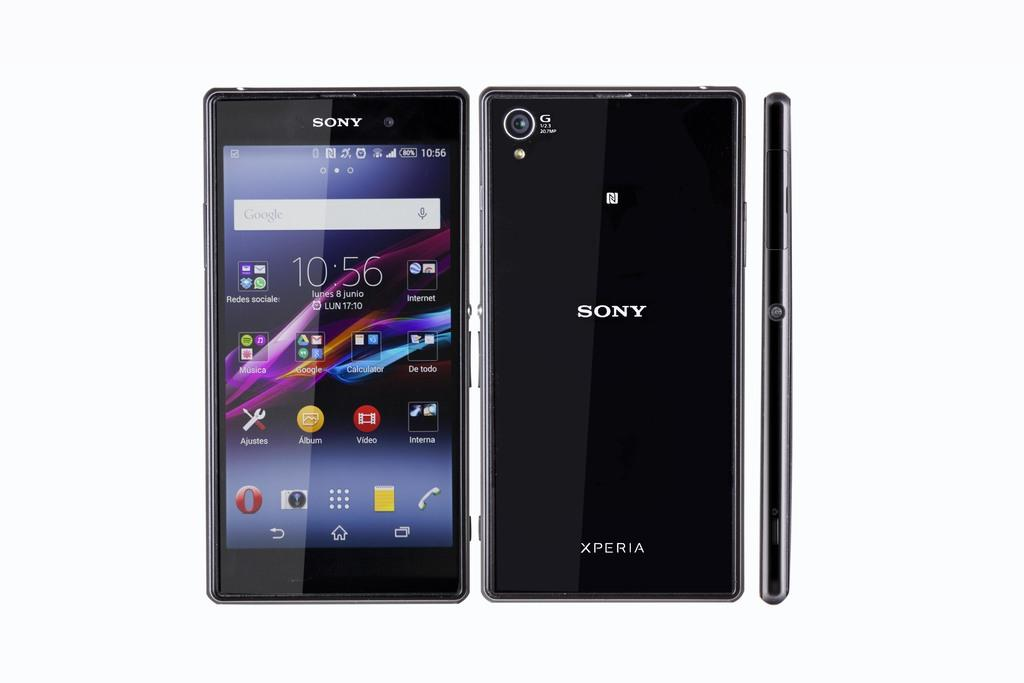Provide a one-sentence caption for the provided image. a phone that has the word Sony on it. 